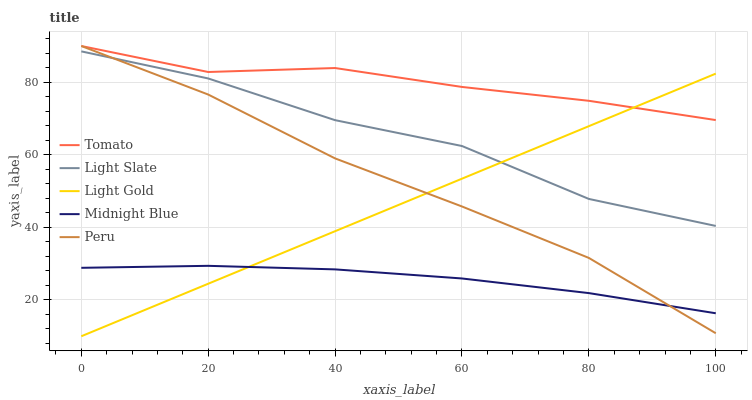Does Light Slate have the minimum area under the curve?
Answer yes or no. No. Does Light Slate have the maximum area under the curve?
Answer yes or no. No. Is Light Slate the smoothest?
Answer yes or no. No. Is Light Gold the roughest?
Answer yes or no. No. Does Light Slate have the lowest value?
Answer yes or no. No. Does Light Slate have the highest value?
Answer yes or no. No. Is Light Slate less than Tomato?
Answer yes or no. Yes. Is Light Slate greater than Midnight Blue?
Answer yes or no. Yes. Does Light Slate intersect Tomato?
Answer yes or no. No. 